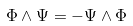Convert formula to latex. <formula><loc_0><loc_0><loc_500><loc_500>\Phi \wedge \Psi = - \Psi \wedge \Phi</formula> 